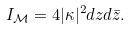<formula> <loc_0><loc_0><loc_500><loc_500>I _ { \mathcal { M } } = 4 | \kappa | ^ { 2 } d z d { \bar { z } } .</formula> 